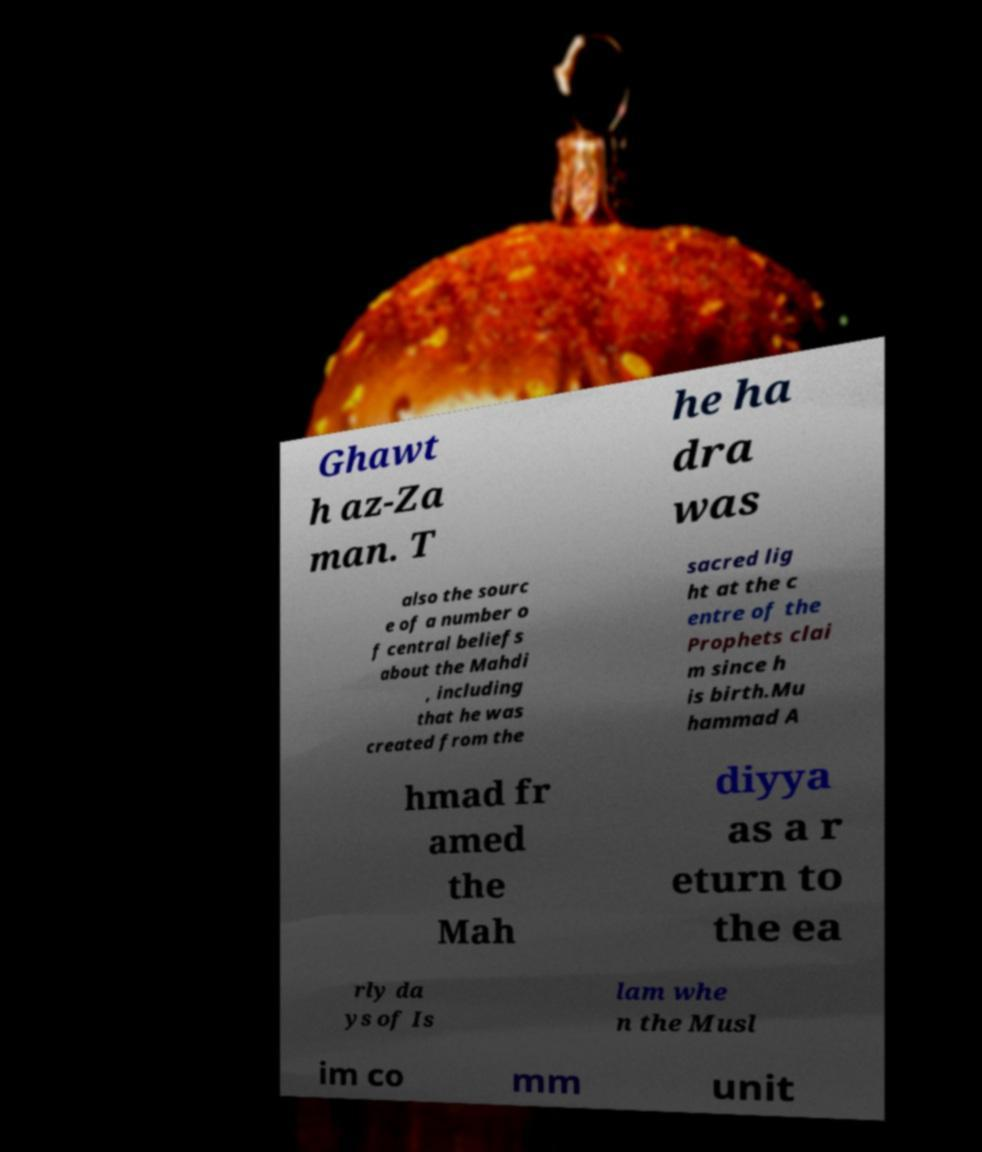I need the written content from this picture converted into text. Can you do that? Ghawt h az-Za man. T he ha dra was also the sourc e of a number o f central beliefs about the Mahdi , including that he was created from the sacred lig ht at the c entre of the Prophets clai m since h is birth.Mu hammad A hmad fr amed the Mah diyya as a r eturn to the ea rly da ys of Is lam whe n the Musl im co mm unit 